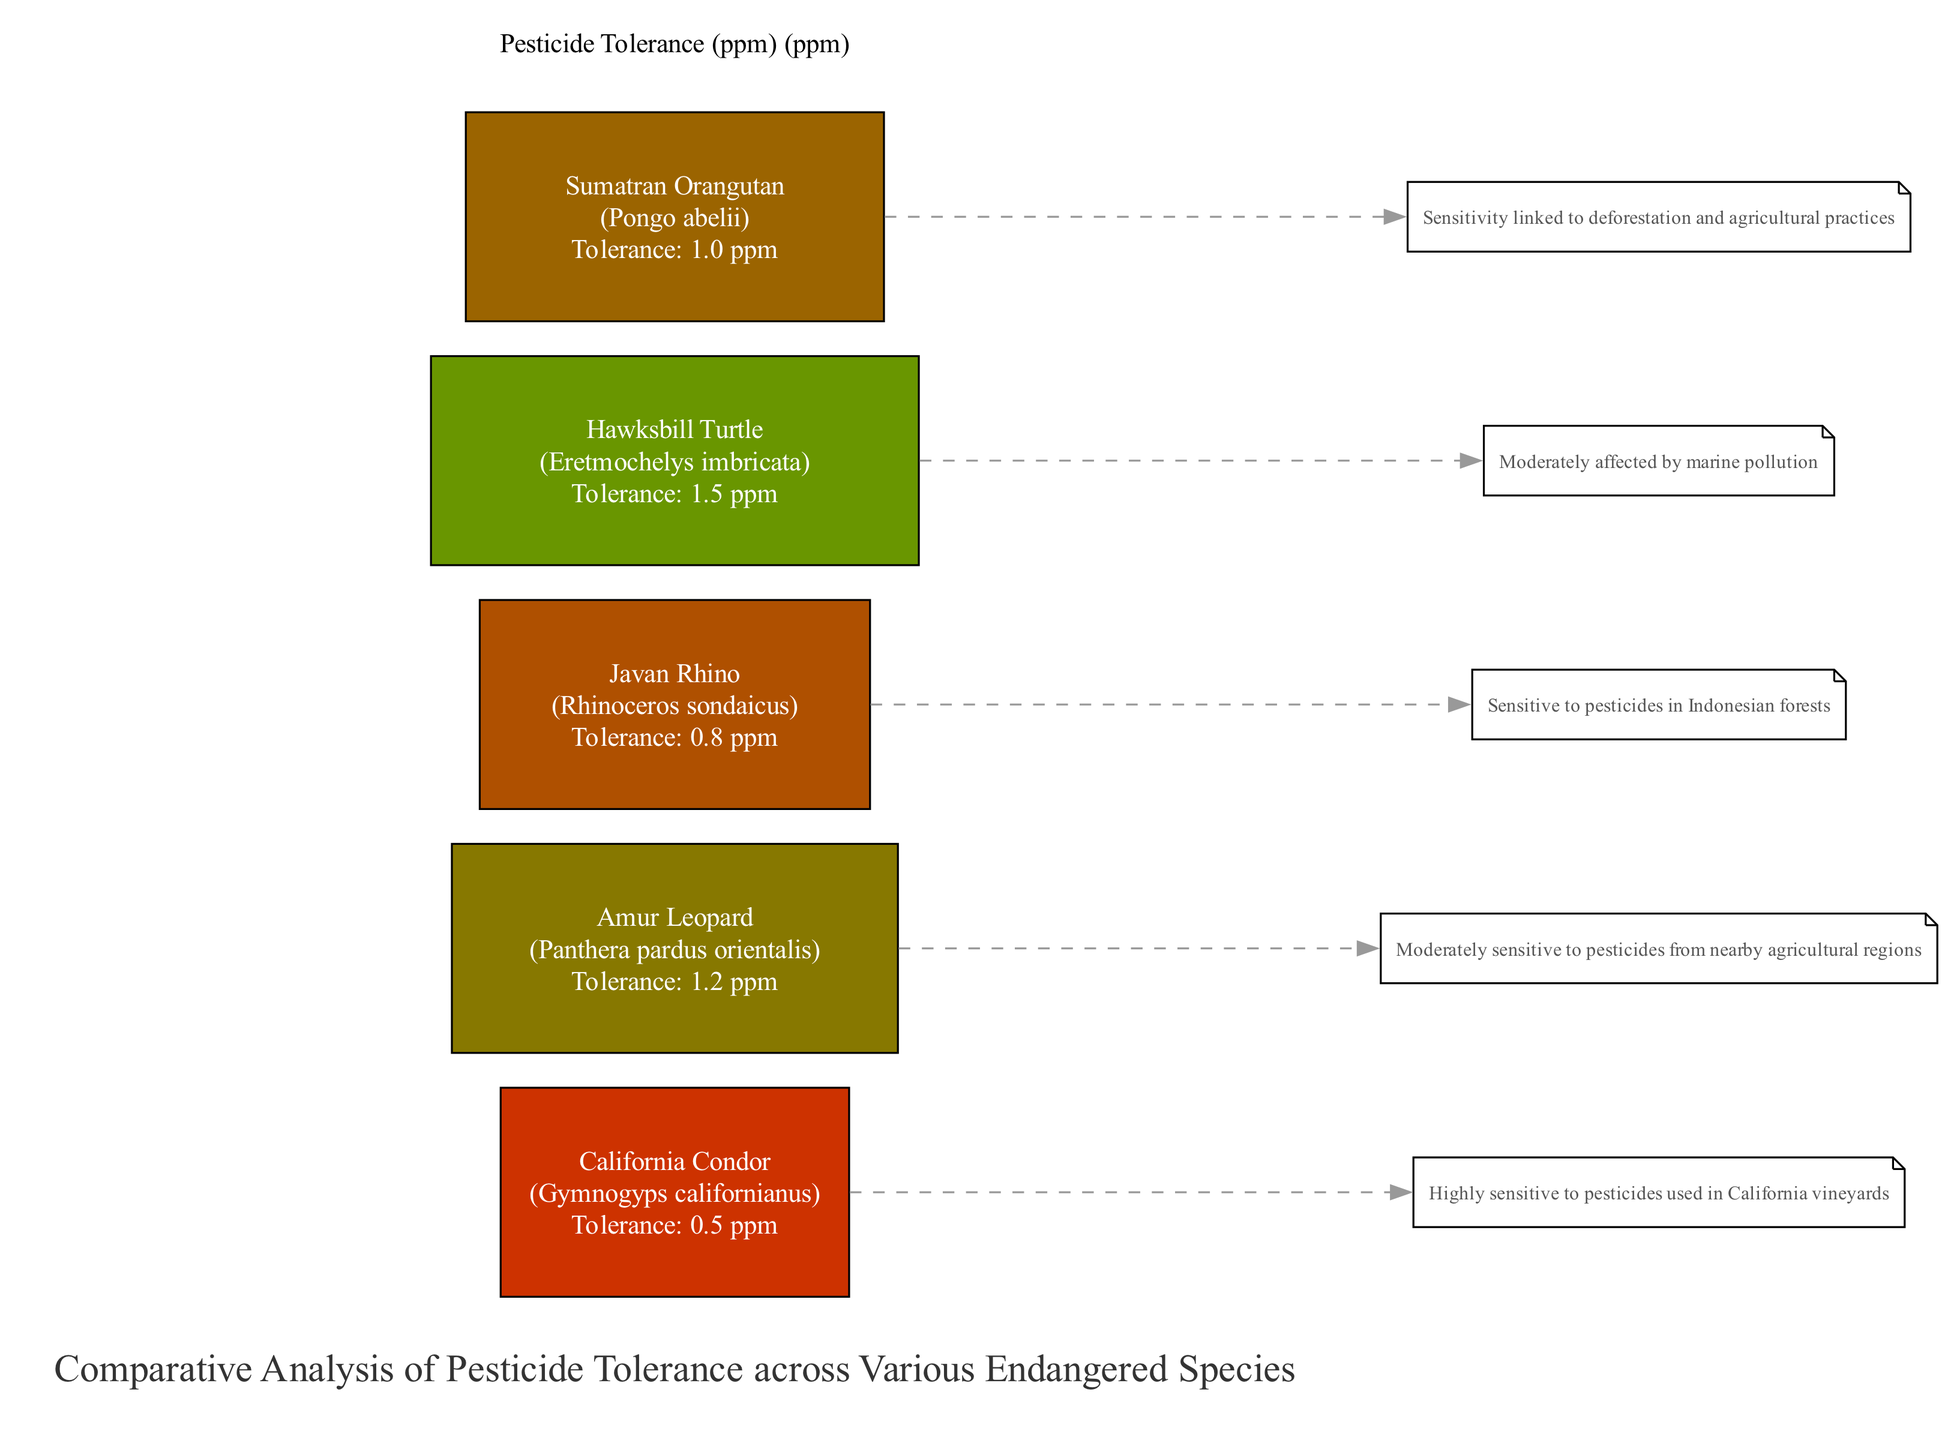What is the pesticide tolerance level of the Hawksbill Turtle? The diagram lists the Hawksbill Turtle in the bar chart with a specified tolerance of 1.5 ppm. By directly referring to the bar corresponding to the Hawksbill Turtle, we can see this value.
Answer: 1.5 ppm Which species has the lowest pesticide tolerance? Among all the species represented in the diagram, the California Condor has the lowest tolerance level at 0.5 ppm, as indicated by its bar height.
Answer: California Condor How many species are represented in the diagram? The diagram features five distinct species, which can be counted by looking at each unique bar on the x-axis labeled with a different endangered species.
Answer: 5 What is the pesticide tolerance of the Amur Leopard compared to the Javan Rhino? The diagram shows that the Amur Leopard has a tolerance of 1.2 ppm while the Javan Rhino has a level of 0.8 ppm. A comparison of these values indicates that the Amur Leopard has a higher tolerance level than the Javan Rhino.
Answer: Amur Leopard has higher tolerance What is the relationship between pesticide tolerance and the California Condor's sensitivity? The diagram directly indicates that the California Condor is highly sensitive to pesticides, which is reflected in its low tolerance level of 0.5 ppm, showing that lower tolerance correlates with higher sensitivity to pesticide effects.
Answer: Inverse relationship Which species has a tolerance value of 1.0 ppm? By inspecting the quantitative values next to the Sumatran Orangutan's bar in the diagram, we find that its specified pesticide tolerance is 1.0 ppm.
Answer: Sumatran Orangutan What annotation is given for the Javan Rhino? The diagram provides an annotation stating that the Javan Rhino is sensitive to pesticides in Indonesian forests. This information is found under the respective bar that represents this species.
Answer: Sensitive to pesticides in Indonesian forests How many species have a tolerance level above 1.0 ppm? Observing the bar chart, the species with a tolerance above 1.0 ppm are the Amur Leopard (1.2 ppm) and Hawksbill Turtle (1.5 ppm). Counting these two gives the result.
Answer: 2 Which scientific name corresponds to the California Condor? In the legend section of the diagram, it is indicated that the scientific name for the California Condor is "Gymnogyps californianus". This can be confirmed by matching the species with its corresponding scientific name.
Answer: Gymnogyps californianus 